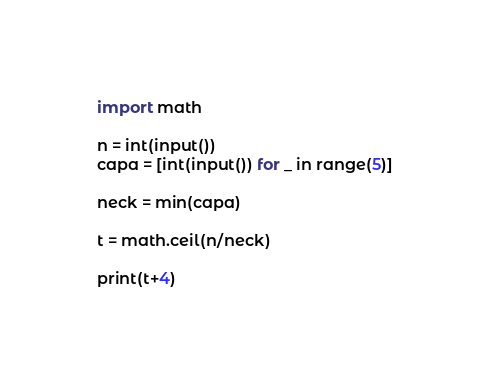<code> <loc_0><loc_0><loc_500><loc_500><_Python_>import math

n = int(input())
capa = [int(input()) for _ in range(5)]

neck = min(capa)

t = math.ceil(n/neck)

print(t+4)
</code> 